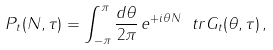<formula> <loc_0><loc_0><loc_500><loc_500>P _ { t } ( N , \tau ) = \int _ { - \pi } ^ { \pi } \frac { d \theta } { 2 \pi } \, e ^ { + i \theta N } \ t r G _ { t } ( \theta , \tau ) \, ,</formula> 